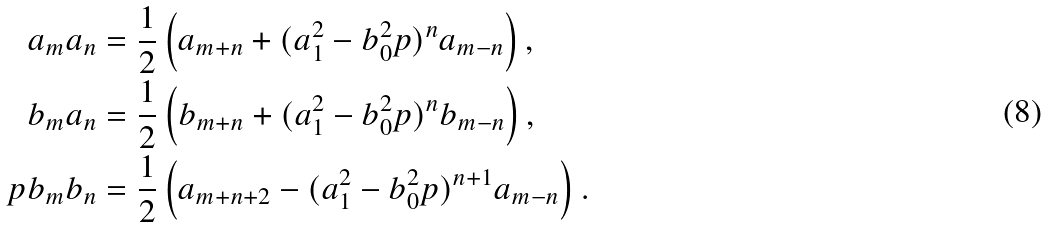<formula> <loc_0><loc_0><loc_500><loc_500>a _ { m } a _ { n } & = \frac { 1 } { 2 } \left ( a _ { m + n } + ( a _ { 1 } ^ { 2 } - b _ { 0 } ^ { 2 } p ) ^ { n } a _ { m - n } \right ) , \\ b _ { m } a _ { n } & = \frac { 1 } { 2 } \left ( b _ { m + n } + ( a _ { 1 } ^ { 2 } - b _ { 0 } ^ { 2 } p ) ^ { n } b _ { m - n } \right ) , \\ p b _ { m } b _ { n } & = \frac { 1 } { 2 } \left ( a _ { m + n + 2 } - ( a _ { 1 } ^ { 2 } - b _ { 0 } ^ { 2 } p ) ^ { n + 1 } a _ { m - n } \right ) . \\</formula> 